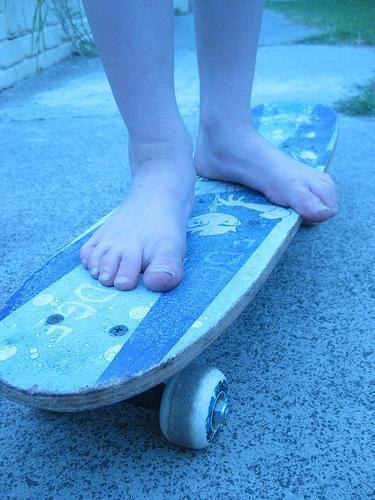How many wheels are showing?
Give a very brief answer. 1. 